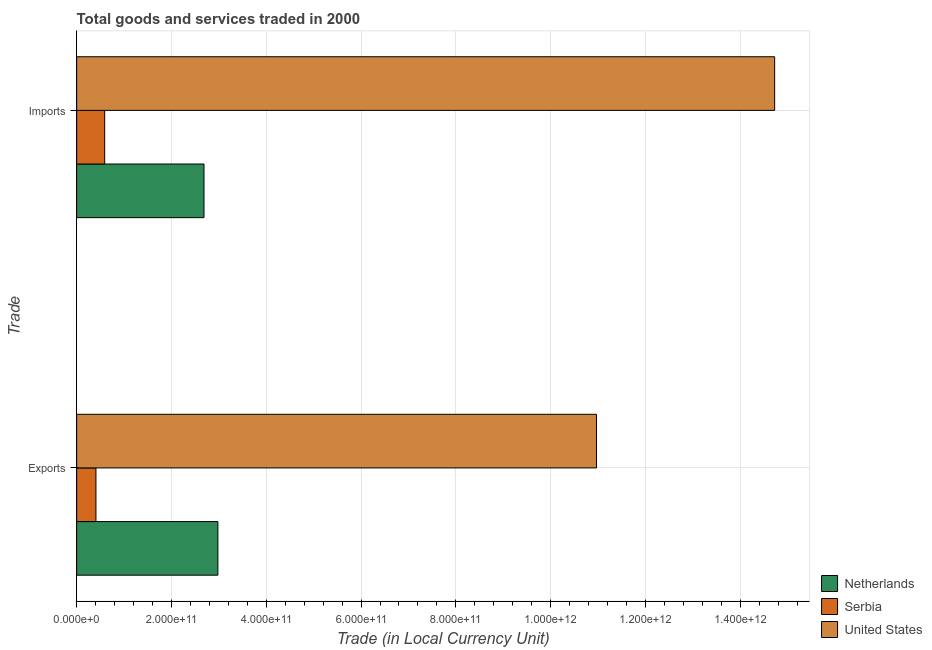How many different coloured bars are there?
Provide a succinct answer. 3. How many bars are there on the 2nd tick from the bottom?
Make the answer very short. 3. What is the label of the 1st group of bars from the top?
Make the answer very short. Imports. What is the imports of goods and services in Serbia?
Keep it short and to the point. 5.91e+1. Across all countries, what is the maximum imports of goods and services?
Give a very brief answer. 1.47e+12. Across all countries, what is the minimum export of goods and services?
Offer a very short reply. 4.07e+1. In which country was the imports of goods and services maximum?
Offer a very short reply. United States. In which country was the export of goods and services minimum?
Provide a succinct answer. Serbia. What is the total export of goods and services in the graph?
Your answer should be very brief. 1.44e+12. What is the difference between the imports of goods and services in Serbia and that in Netherlands?
Provide a short and direct response. -2.10e+11. What is the difference between the imports of goods and services in Serbia and the export of goods and services in Netherlands?
Your answer should be very brief. -2.39e+11. What is the average imports of goods and services per country?
Make the answer very short. 6.00e+11. What is the difference between the export of goods and services and imports of goods and services in United States?
Your answer should be very brief. -3.76e+11. What is the ratio of the export of goods and services in United States to that in Serbia?
Make the answer very short. 26.95. Is the imports of goods and services in United States less than that in Netherlands?
Your response must be concise. No. What does the 2nd bar from the top in Imports represents?
Keep it short and to the point. Serbia. What does the 1st bar from the bottom in Exports represents?
Provide a short and direct response. Netherlands. Are all the bars in the graph horizontal?
Offer a very short reply. Yes. How many countries are there in the graph?
Give a very brief answer. 3. What is the difference between two consecutive major ticks on the X-axis?
Keep it short and to the point. 2.00e+11. Does the graph contain any zero values?
Your response must be concise. No. Does the graph contain grids?
Your answer should be very brief. Yes. Where does the legend appear in the graph?
Provide a succinct answer. Bottom right. How many legend labels are there?
Your response must be concise. 3. How are the legend labels stacked?
Give a very brief answer. Vertical. What is the title of the graph?
Offer a terse response. Total goods and services traded in 2000. What is the label or title of the X-axis?
Ensure brevity in your answer.  Trade (in Local Currency Unit). What is the label or title of the Y-axis?
Offer a terse response. Trade. What is the Trade (in Local Currency Unit) of Netherlands in Exports?
Provide a short and direct response. 2.98e+11. What is the Trade (in Local Currency Unit) in Serbia in Exports?
Your answer should be very brief. 4.07e+1. What is the Trade (in Local Currency Unit) in United States in Exports?
Provide a short and direct response. 1.10e+12. What is the Trade (in Local Currency Unit) of Netherlands in Imports?
Provide a succinct answer. 2.69e+11. What is the Trade (in Local Currency Unit) in Serbia in Imports?
Your answer should be very brief. 5.91e+1. What is the Trade (in Local Currency Unit) of United States in Imports?
Offer a terse response. 1.47e+12. Across all Trade, what is the maximum Trade (in Local Currency Unit) in Netherlands?
Offer a very short reply. 2.98e+11. Across all Trade, what is the maximum Trade (in Local Currency Unit) in Serbia?
Provide a succinct answer. 5.91e+1. Across all Trade, what is the maximum Trade (in Local Currency Unit) in United States?
Provide a succinct answer. 1.47e+12. Across all Trade, what is the minimum Trade (in Local Currency Unit) in Netherlands?
Provide a succinct answer. 2.69e+11. Across all Trade, what is the minimum Trade (in Local Currency Unit) of Serbia?
Give a very brief answer. 4.07e+1. Across all Trade, what is the minimum Trade (in Local Currency Unit) in United States?
Make the answer very short. 1.10e+12. What is the total Trade (in Local Currency Unit) of Netherlands in the graph?
Offer a very short reply. 5.67e+11. What is the total Trade (in Local Currency Unit) in Serbia in the graph?
Your answer should be very brief. 9.99e+1. What is the total Trade (in Local Currency Unit) of United States in the graph?
Ensure brevity in your answer.  2.57e+12. What is the difference between the Trade (in Local Currency Unit) of Netherlands in Exports and that in Imports?
Your answer should be compact. 2.93e+1. What is the difference between the Trade (in Local Currency Unit) in Serbia in Exports and that in Imports?
Offer a very short reply. -1.84e+1. What is the difference between the Trade (in Local Currency Unit) in United States in Exports and that in Imports?
Provide a succinct answer. -3.76e+11. What is the difference between the Trade (in Local Currency Unit) of Netherlands in Exports and the Trade (in Local Currency Unit) of Serbia in Imports?
Give a very brief answer. 2.39e+11. What is the difference between the Trade (in Local Currency Unit) in Netherlands in Exports and the Trade (in Local Currency Unit) in United States in Imports?
Provide a succinct answer. -1.17e+12. What is the difference between the Trade (in Local Currency Unit) in Serbia in Exports and the Trade (in Local Currency Unit) in United States in Imports?
Provide a succinct answer. -1.43e+12. What is the average Trade (in Local Currency Unit) in Netherlands per Trade?
Make the answer very short. 2.83e+11. What is the average Trade (in Local Currency Unit) of Serbia per Trade?
Make the answer very short. 4.99e+1. What is the average Trade (in Local Currency Unit) of United States per Trade?
Your answer should be very brief. 1.28e+12. What is the difference between the Trade (in Local Currency Unit) of Netherlands and Trade (in Local Currency Unit) of Serbia in Exports?
Your response must be concise. 2.57e+11. What is the difference between the Trade (in Local Currency Unit) in Netherlands and Trade (in Local Currency Unit) in United States in Exports?
Provide a succinct answer. -7.99e+11. What is the difference between the Trade (in Local Currency Unit) of Serbia and Trade (in Local Currency Unit) of United States in Exports?
Give a very brief answer. -1.06e+12. What is the difference between the Trade (in Local Currency Unit) of Netherlands and Trade (in Local Currency Unit) of Serbia in Imports?
Provide a short and direct response. 2.10e+11. What is the difference between the Trade (in Local Currency Unit) in Netherlands and Trade (in Local Currency Unit) in United States in Imports?
Offer a very short reply. -1.20e+12. What is the difference between the Trade (in Local Currency Unit) of Serbia and Trade (in Local Currency Unit) of United States in Imports?
Your response must be concise. -1.41e+12. What is the ratio of the Trade (in Local Currency Unit) of Netherlands in Exports to that in Imports?
Give a very brief answer. 1.11. What is the ratio of the Trade (in Local Currency Unit) of Serbia in Exports to that in Imports?
Your answer should be very brief. 0.69. What is the ratio of the Trade (in Local Currency Unit) of United States in Exports to that in Imports?
Your response must be concise. 0.74. What is the difference between the highest and the second highest Trade (in Local Currency Unit) in Netherlands?
Provide a succinct answer. 2.93e+1. What is the difference between the highest and the second highest Trade (in Local Currency Unit) in Serbia?
Your answer should be very brief. 1.84e+1. What is the difference between the highest and the second highest Trade (in Local Currency Unit) of United States?
Your response must be concise. 3.76e+11. What is the difference between the highest and the lowest Trade (in Local Currency Unit) in Netherlands?
Make the answer very short. 2.93e+1. What is the difference between the highest and the lowest Trade (in Local Currency Unit) in Serbia?
Your response must be concise. 1.84e+1. What is the difference between the highest and the lowest Trade (in Local Currency Unit) of United States?
Your answer should be compact. 3.76e+11. 